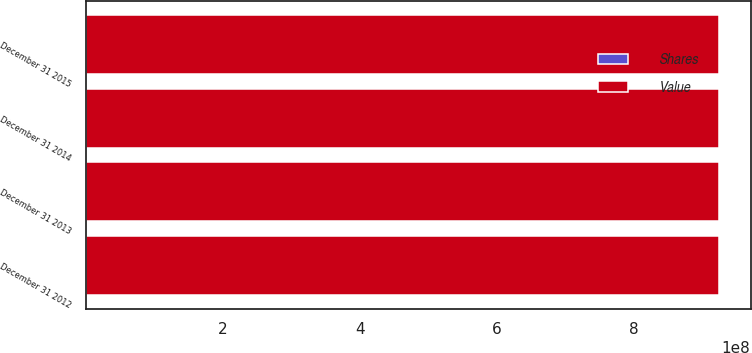Convert chart to OTSL. <chart><loc_0><loc_0><loc_500><loc_500><stacked_bar_chart><ecel><fcel>December 31 2012<fcel>December 31 2013<fcel>December 31 2014<fcel>December 31 2015<nl><fcel>Shares<fcel>2051<fcel>2051<fcel>2051<fcel>2051<nl><fcel>Value<fcel>9.23893e+08<fcel>9.23893e+08<fcel>9.23893e+08<fcel>9.23893e+08<nl></chart> 